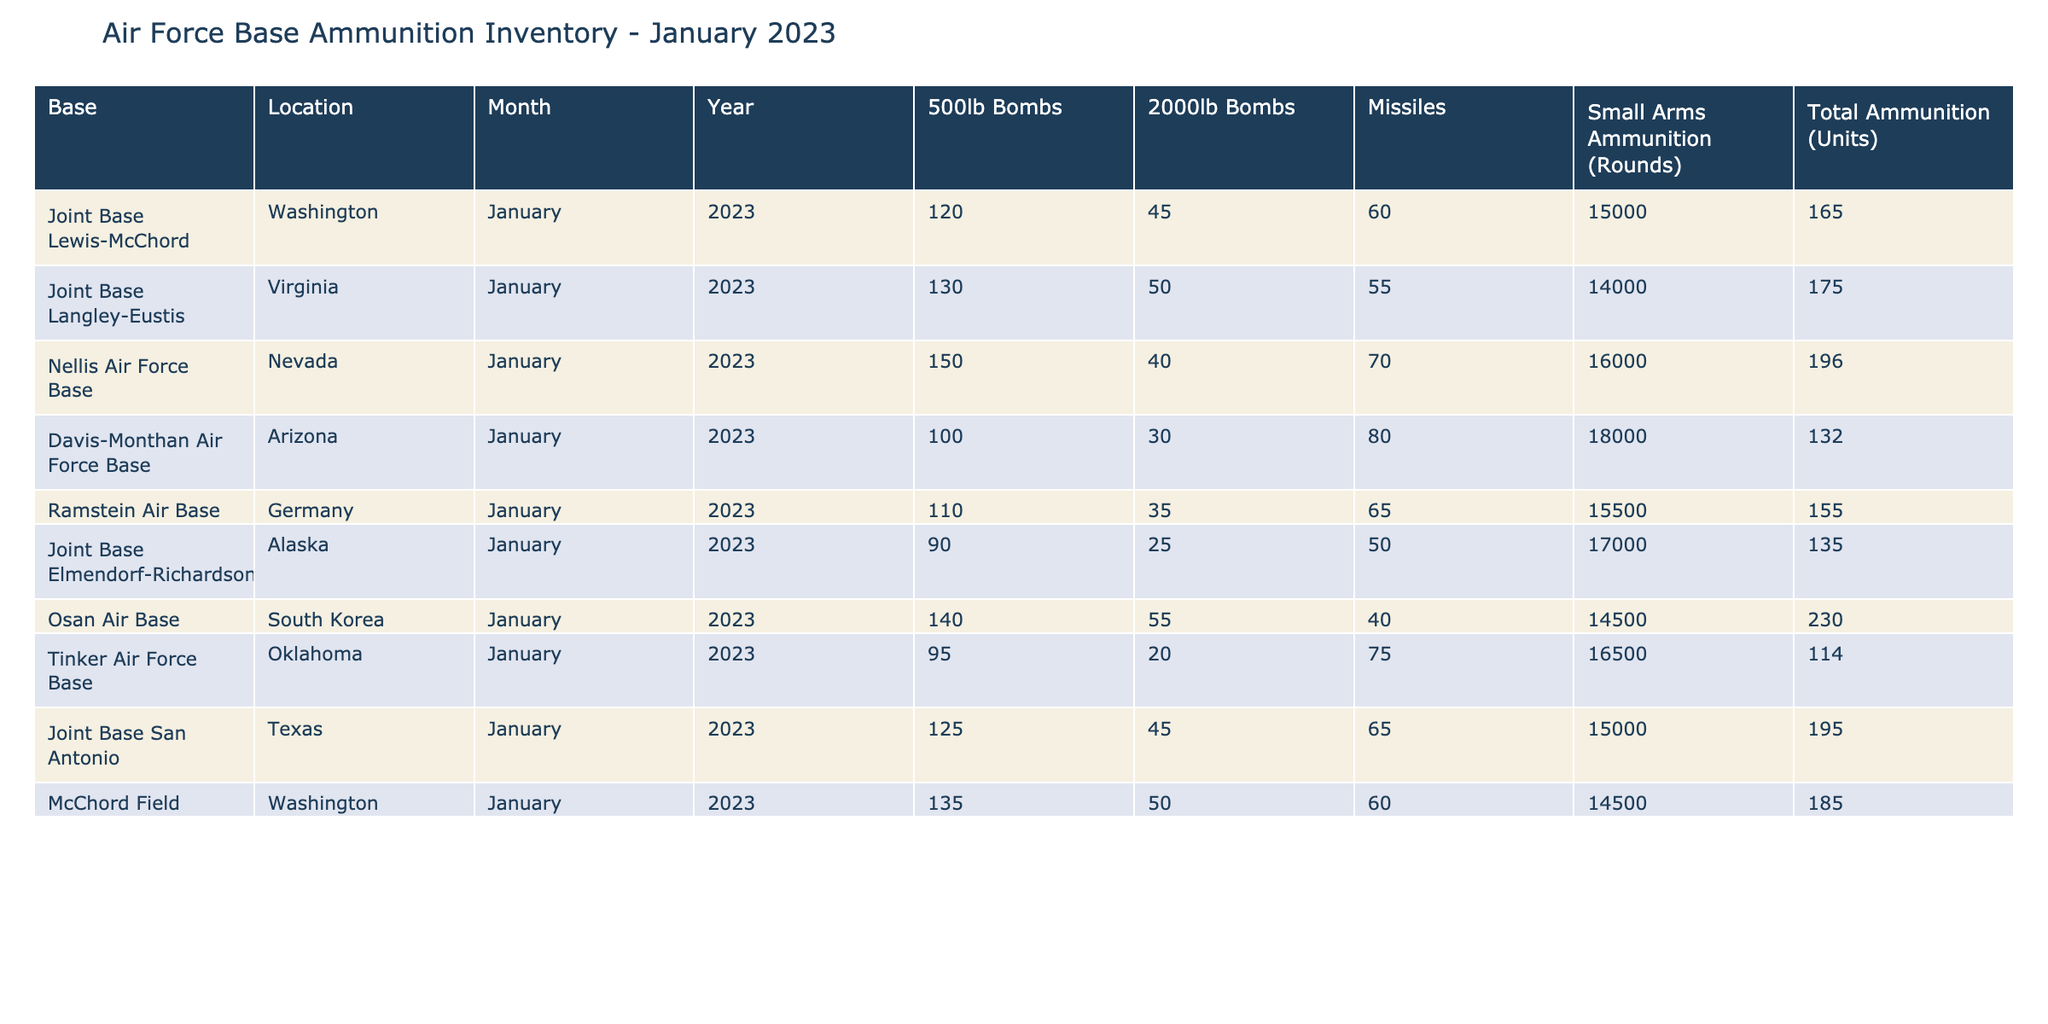What is the total number of 2000lb bombs available across all bases? To find the total number of 2000lb bombs, add the units listed for each base: 45 (Joint Base Lewis-McChord) + 50 (Joint Base Langley-Eustis) + 40 (Nellis Air Force Base) + 30 (Davis-Monthan Air Force Base) + 35 (Ramstein Air Base) + 25 (Joint Base Elmendorf-Richardson) + 55 (Osan Air Base) + 20 (Tinker Air Force Base) + 45 (Joint Base San Antonio) + 50 (McChord Field) = 400
Answer: 400 Which Air Force base has the highest total ammunition supply? To determine which base has the highest total ammunition supply, compare the total ammunition units for each base, identifying the maximum value. The maximum is 230 at Osan Air Base.
Answer: Osan Air Base What is the average number of 500lb bombs across all bases? Calculate the average by summing all 500lb bombs: 120 + 130 + 150 + 100 + 110 + 90 + 140 + 95 + 125 + 135 = 1,195. There are 10 bases, so divide by 10: 1,195 / 10 = 119.5.
Answer: 119.5 Is the total number of missiles at Davis-Monthan Air Force Base greater than the total at Joint Base Lewis-McChord? Compare the number of missiles at Davis-Monthan (80) to Joint Base Lewis-McChord (60). Since 80 is greater than 60, the statement is true.
Answer: Yes What is the total amount of Small Arms Ammunition across all bases? To find the total amount of Small Arms Ammunition, add the rounds listed for each base: 15000 (Joint Base Lewis-McChord) + 14000 (Joint Base Langley-Eustis) + 16000 (Nellis Air Force Base) + 18000 (Davis-Monthan Air Force Base) + 15500 (Ramstein Air Base) + 17000 (Joint Base Elmendorf-Richardson) + 14500 (Osan Air Base) + 16500 (Tinker Air Force Base) + 15000 (Joint Base San Antonio) + 14500 (McChord Field) = 1,563,500.
Answer: 1,563,500 Is the total ammunition at Nellis Air Force Base less than the total at Tinker Air Force Base? Compare the total ammunition at Nellis Air Force Base (196) to Tinker Air Force Base (114). Since 196 is greater than 114, the statement is false.
Answer: No Which base has the lowest number of 500lb bombs? Identify the minimum number of 500lb bombs by checking each base's count and finding it is 90 at Joint Base Elmendorf-Richardson.
Answer: Joint Base Elmendorf-Richardson What is the difference in total ammunition supply between Ramstein Air Base and McChord Field? Calculate the difference by finding their total ammunition supplies: Ramstein (155) - McChord Field (185). The difference is 155 - 185 = -30, indicating that McChord has more.
Answer: 30 (McChord Field has more) 